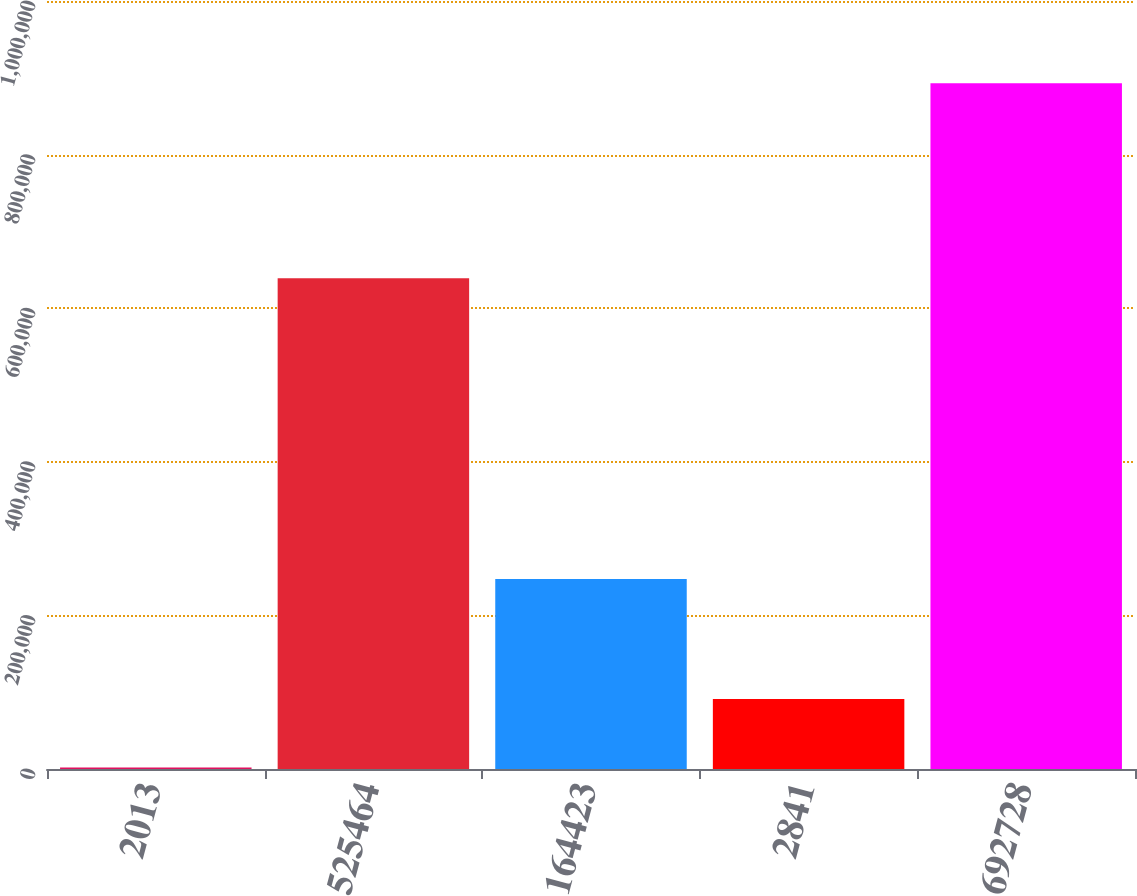Convert chart to OTSL. <chart><loc_0><loc_0><loc_500><loc_500><bar_chart><fcel>2013<fcel>525464<fcel>164423<fcel>2841<fcel>692728<nl><fcel>2012<fcel>639134<fcel>247479<fcel>91109.4<fcel>892986<nl></chart> 